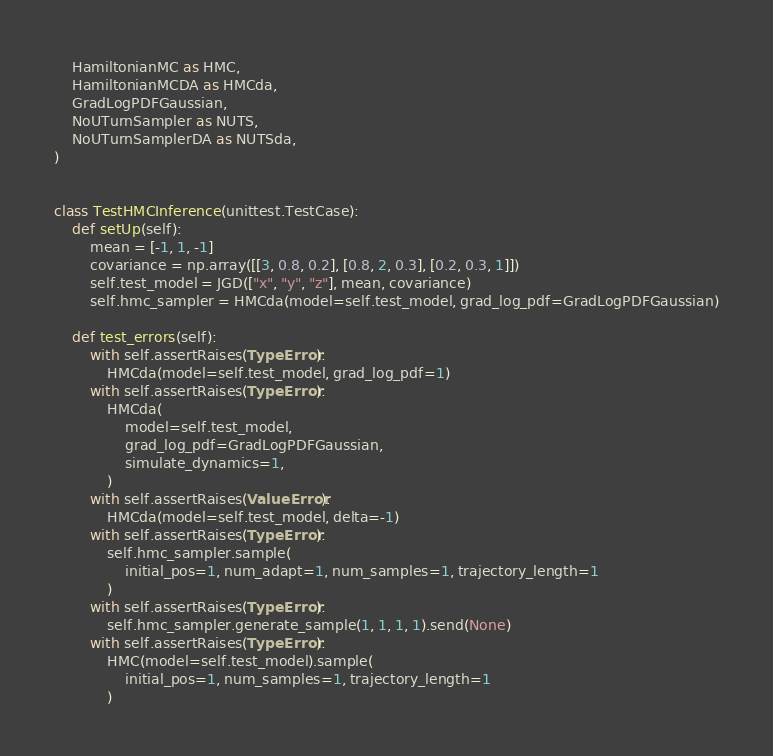Convert code to text. <code><loc_0><loc_0><loc_500><loc_500><_Python_>    HamiltonianMC as HMC,
    HamiltonianMCDA as HMCda,
    GradLogPDFGaussian,
    NoUTurnSampler as NUTS,
    NoUTurnSamplerDA as NUTSda,
)


class TestHMCInference(unittest.TestCase):
    def setUp(self):
        mean = [-1, 1, -1]
        covariance = np.array([[3, 0.8, 0.2], [0.8, 2, 0.3], [0.2, 0.3, 1]])
        self.test_model = JGD(["x", "y", "z"], mean, covariance)
        self.hmc_sampler = HMCda(model=self.test_model, grad_log_pdf=GradLogPDFGaussian)

    def test_errors(self):
        with self.assertRaises(TypeError):
            HMCda(model=self.test_model, grad_log_pdf=1)
        with self.assertRaises(TypeError):
            HMCda(
                model=self.test_model,
                grad_log_pdf=GradLogPDFGaussian,
                simulate_dynamics=1,
            )
        with self.assertRaises(ValueError):
            HMCda(model=self.test_model, delta=-1)
        with self.assertRaises(TypeError):
            self.hmc_sampler.sample(
                initial_pos=1, num_adapt=1, num_samples=1, trajectory_length=1
            )
        with self.assertRaises(TypeError):
            self.hmc_sampler.generate_sample(1, 1, 1, 1).send(None)
        with self.assertRaises(TypeError):
            HMC(model=self.test_model).sample(
                initial_pos=1, num_samples=1, trajectory_length=1
            )</code> 